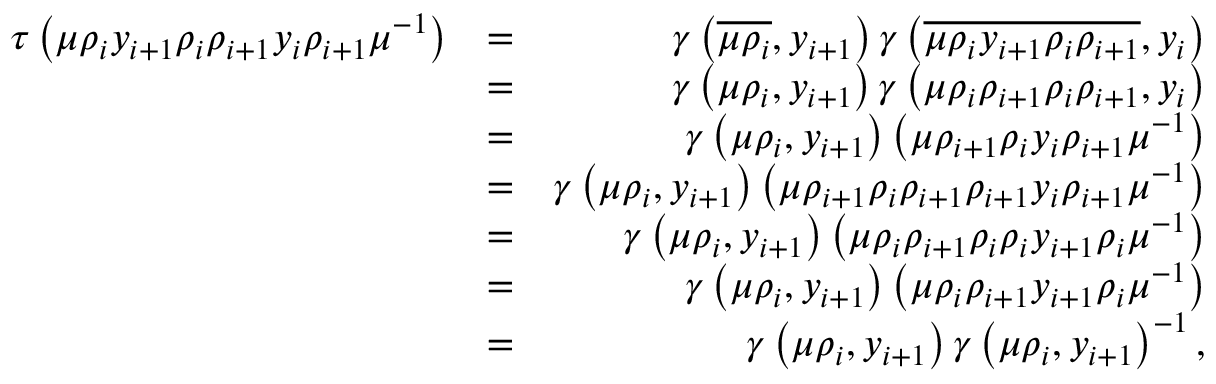<formula> <loc_0><loc_0><loc_500><loc_500>\begin{array} { r l r } { \tau \left ( \mu \rho _ { i } y _ { i + 1 } \rho _ { i } \rho _ { i + 1 } y _ { i } \rho _ { i + 1 } \mu ^ { - 1 } \right ) } & { = } & { \gamma \left ( \overline { { \mu \rho _ { i } } } , y _ { i + 1 } \right ) \gamma \left ( \overline { { \mu \rho _ { i } y _ { i + 1 } \rho _ { i } \rho _ { i + 1 } } } , y _ { i } \right ) } \\ & { = } & { \gamma \left ( \mu \rho _ { i } , y _ { i + 1 } \right ) \gamma \left ( \mu \rho _ { i } \rho _ { i + 1 } \rho _ { i } \rho _ { i + 1 } , y _ { i } \right ) } \\ & { = } & { \gamma \left ( \mu \rho _ { i } , y _ { i + 1 } \right ) \left ( \mu \rho _ { i + 1 } \rho _ { i } y _ { i } \rho _ { i + 1 } \mu ^ { - 1 } \right ) } \\ & { = } & { \gamma \left ( \mu \rho _ { i } , y _ { i + 1 } \right ) \left ( \mu \rho _ { i + 1 } \rho _ { i } \rho _ { i + 1 } \rho _ { i + 1 } y _ { i } \rho _ { i + 1 } \mu ^ { - 1 } \right ) } \\ & { = } & { \gamma \left ( \mu \rho _ { i } , y _ { i + 1 } \right ) \left ( \mu \rho _ { i } \rho _ { i + 1 } \rho _ { i } \rho _ { i } y _ { i + 1 } \rho _ { i } \mu ^ { - 1 } \right ) } \\ & { = } & { \gamma \left ( \mu \rho _ { i } , y _ { i + 1 } \right ) \left ( \mu \rho _ { i } \rho _ { i + 1 } y _ { i + 1 } \rho _ { i } \mu ^ { - 1 } \right ) } \\ & { = } & { \gamma \left ( \mu \rho _ { i } , y _ { i + 1 } \right ) \gamma \left ( \mu \rho _ { i } , y _ { i + 1 } \right ) ^ { - 1 } , } \end{array}</formula> 